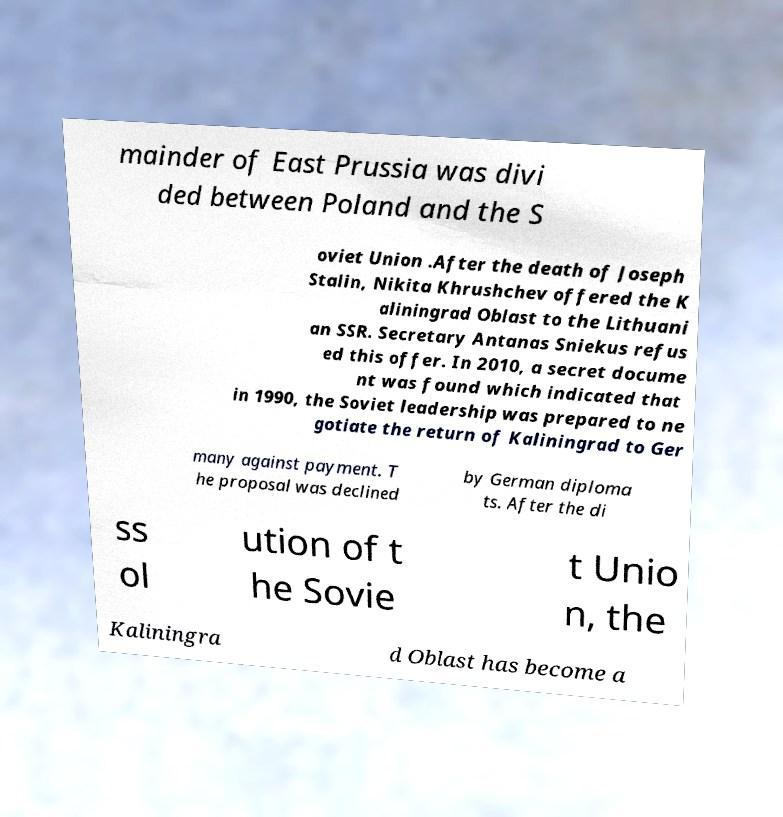For documentation purposes, I need the text within this image transcribed. Could you provide that? mainder of East Prussia was divi ded between Poland and the S oviet Union .After the death of Joseph Stalin, Nikita Khrushchev offered the K aliningrad Oblast to the Lithuani an SSR. Secretary Antanas Sniekus refus ed this offer. In 2010, a secret docume nt was found which indicated that in 1990, the Soviet leadership was prepared to ne gotiate the return of Kaliningrad to Ger many against payment. T he proposal was declined by German diploma ts. After the di ss ol ution of t he Sovie t Unio n, the Kaliningra d Oblast has become a 